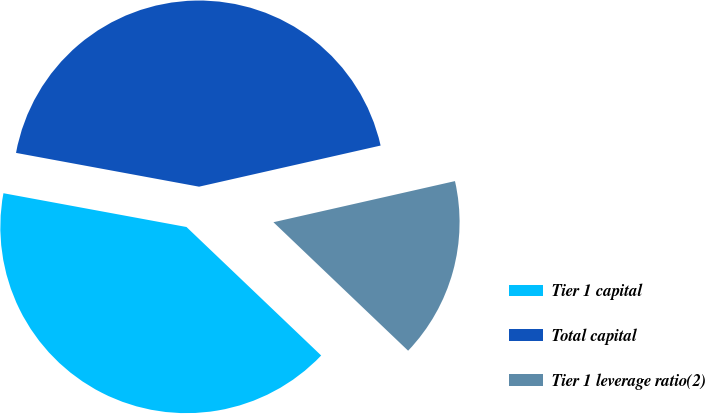Convert chart to OTSL. <chart><loc_0><loc_0><loc_500><loc_500><pie_chart><fcel>Tier 1 capital<fcel>Total capital<fcel>Tier 1 leverage ratio(2)<nl><fcel>40.78%<fcel>43.55%<fcel>15.67%<nl></chart> 